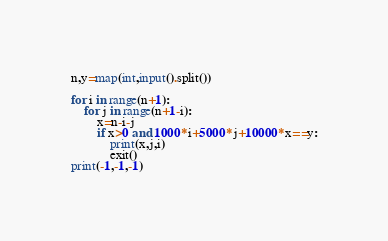<code> <loc_0><loc_0><loc_500><loc_500><_Python_>n,y=map(int,input().split())

for i in range(n+1):
    for j in range(n+1-i):
        x=n-i-j
        if x>0 and 1000*i+5000*j+10000*x==y:
            print(x,j,i)
            exit()
print(-1,-1,-1)
</code> 